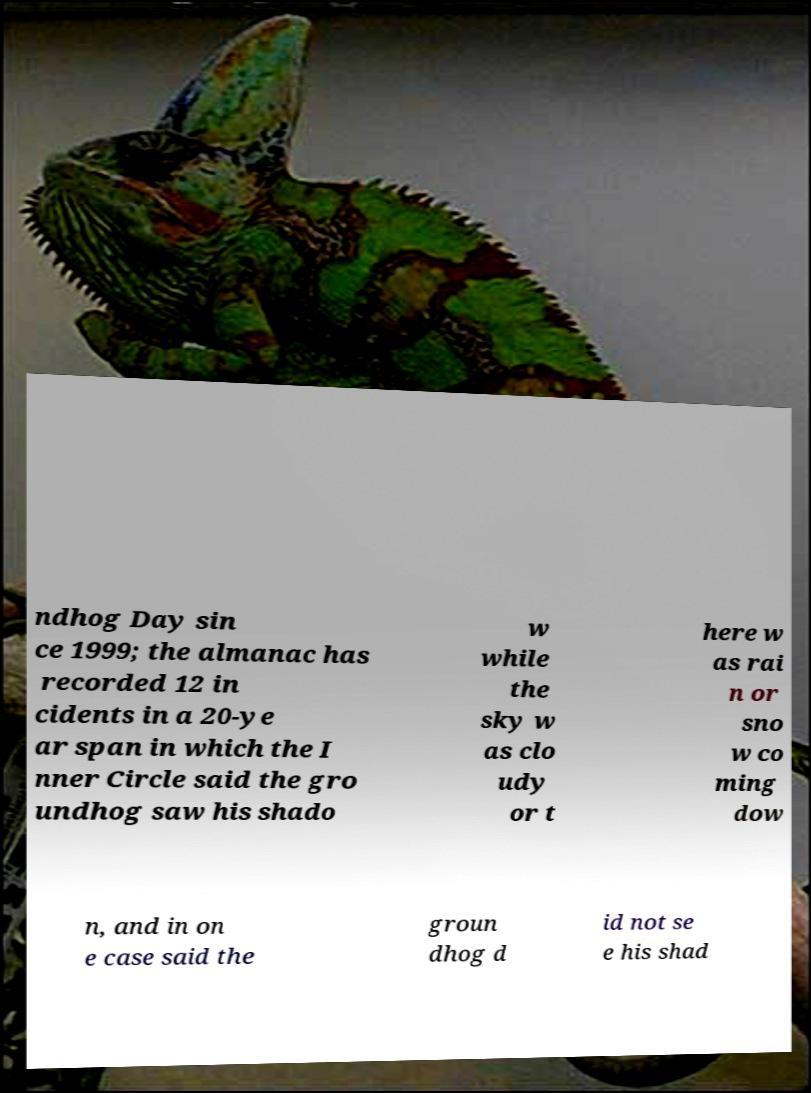Could you assist in decoding the text presented in this image and type it out clearly? ndhog Day sin ce 1999; the almanac has recorded 12 in cidents in a 20-ye ar span in which the I nner Circle said the gro undhog saw his shado w while the sky w as clo udy or t here w as rai n or sno w co ming dow n, and in on e case said the groun dhog d id not se e his shad 